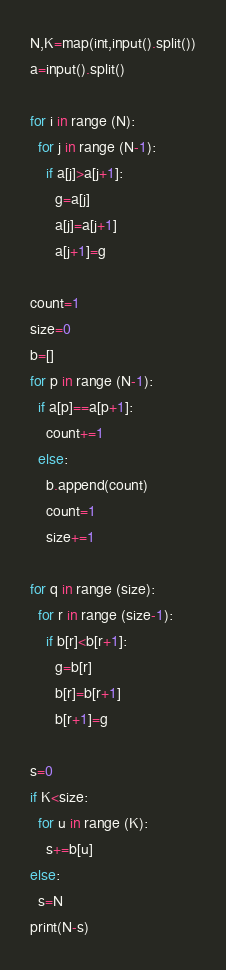Convert code to text. <code><loc_0><loc_0><loc_500><loc_500><_Python_>N,K=map(int,input().split())
a=input().split()

for i in range (N):
  for j in range (N-1):
    if a[j]>a[j+1]:
      g=a[j]
      a[j]=a[j+1]
      a[j+1]=g
    
count=1
size=0
b=[]
for p in range (N-1):
  if a[p]==a[p+1]:
    count+=1
  else:
    b.append(count)
    count=1
    size+=1

for q in range (size):
  for r in range (size-1):
    if b[r]<b[r+1]:
      g=b[r]
      b[r]=b[r+1]
      b[r+1]=g

s=0
if K<size:
  for u in range (K):
    s+=b[u]
else:
  s=N
print(N-s)</code> 